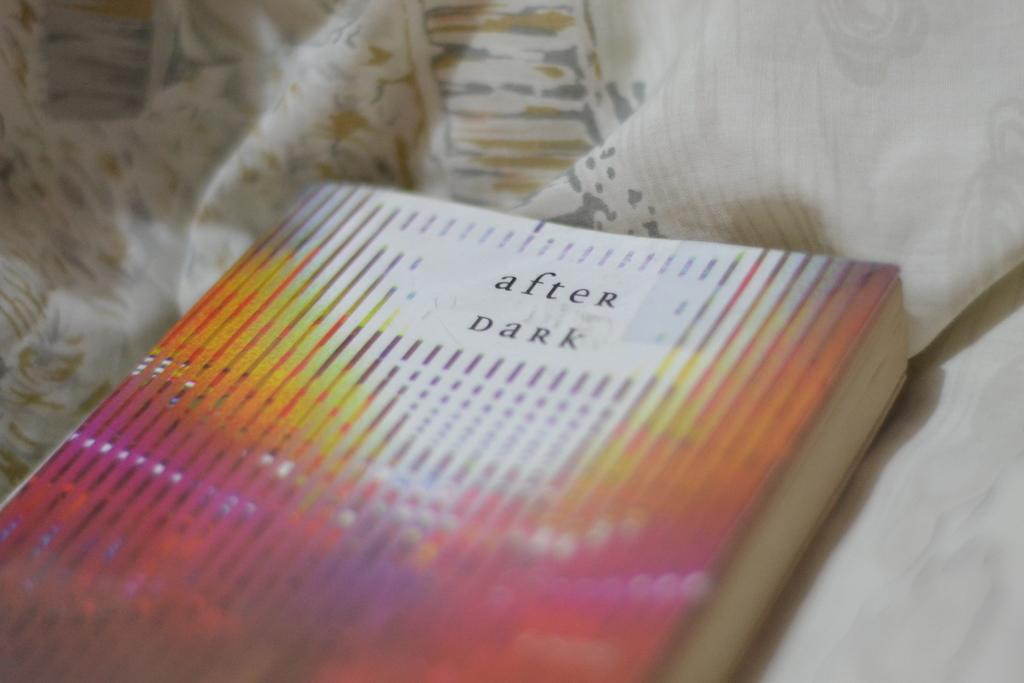<image>
Render a clear and concise summary of the photo. After Dark book laying on a bed sheet. 